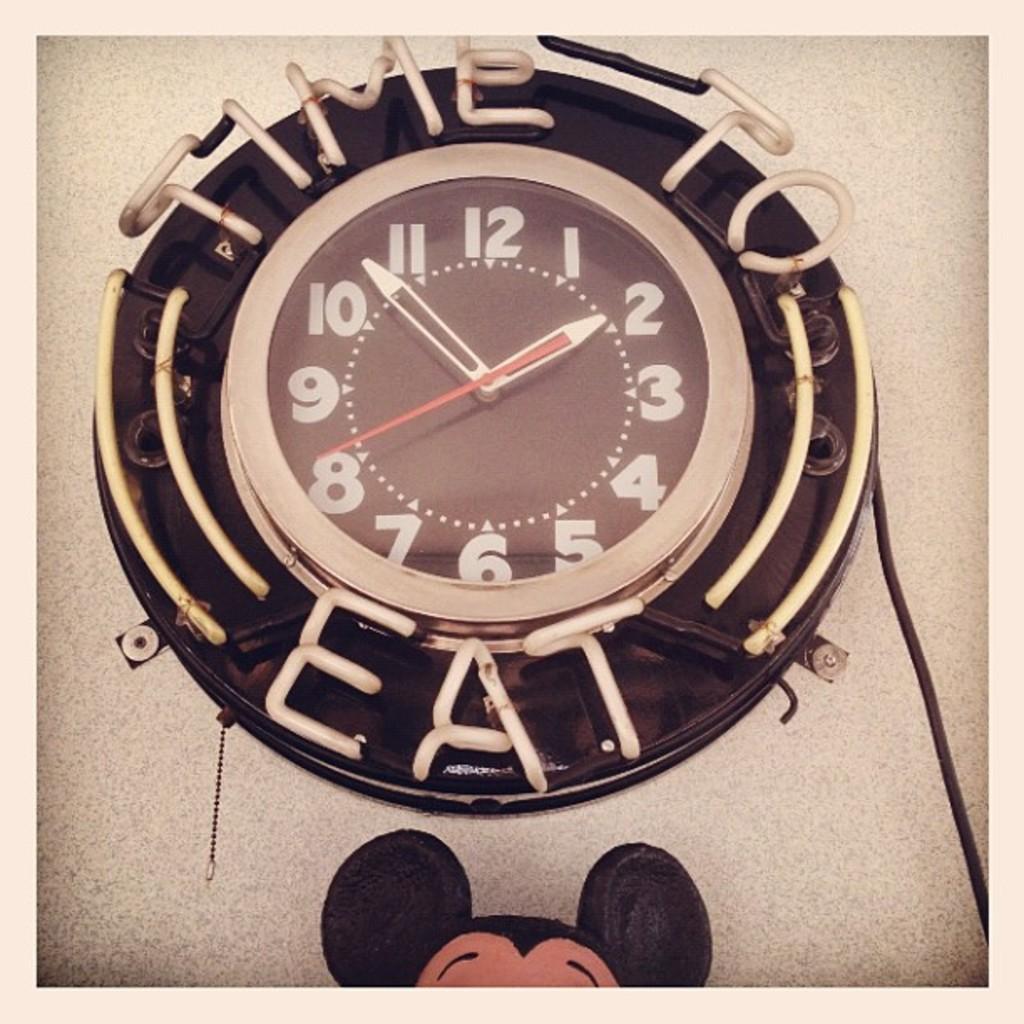According to the clock, it is time to what?
Your answer should be compact. 1:53. What time is on the clock?
Make the answer very short. 1:53. 